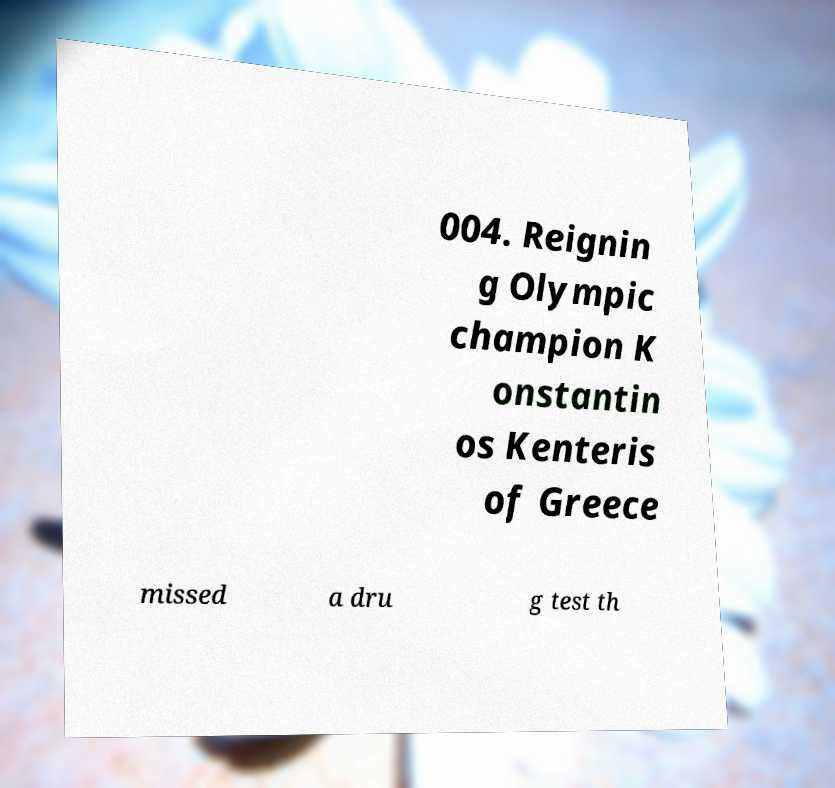Could you extract and type out the text from this image? 004. Reignin g Olympic champion K onstantin os Kenteris of Greece missed a dru g test th 